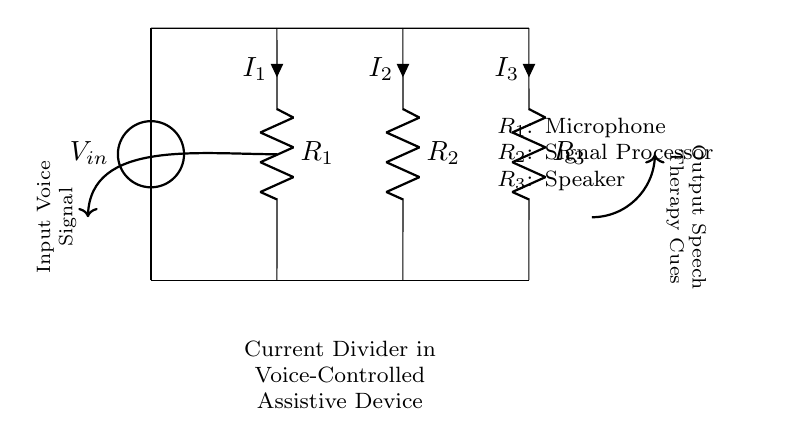What is the total resistance in the circuit? The total resistance in a current divider circuit is determined by the resistors present in parallel. Since there are three resistors (Microphone, Signal Processor, Speaker), we can use the formula for total resistance in a parallel circuit: 1/R_total = 1/R_1 + 1/R_2 + 1/R_3. By substituting the values for R_1, R_2, and R_3, the total resistance can be calculated.
Answer: R_total What are the components in this circuit? The components of the circuit are R_1 (Microphone), R_2 (Signal Processor), and R_3 (Speaker). These components can be identified from the circuit diagram where each resistor is labeled with its corresponding function.
Answer: Microphone, Signal Processor, Speaker Which component has the highest current? In a current divider circuit, the current divides inversely with the resistance. Therefore, the component with the lowest resistance will have the highest current. By analyzing the resistance values of R_1, R_2, and R_3, we can pinpoint which component has the least resistance and thus carries the highest current.
Answer: R_1 (Microphone) What is the direction of current flow? The current flows from the input voltage source through the circuit and divides among the resistors. By following the circuit path from the voltage source through to the ground, we can observe that current flows downwards through the resistors.
Answer: Downwards What does the current divider do in this context? The current divider in this context allows for the allocation of the input voice signal across multiple components. This function enables the voice signal to be processed by the signal processor while also being directed to the speaker for output. This is critical for the functioning of voice-controlled assistive devices for speech therapy.
Answer: Allocates voice signal What happens to the output when the input voltage increases? When the input voltage increases, the output current through the resistors also increases proportionally based on their resistances. In a current divider, an increase in input voltage results in a higher output current being distributed to each of the branches, enhancing the overall response of the device.
Answer: Increases proportionally 